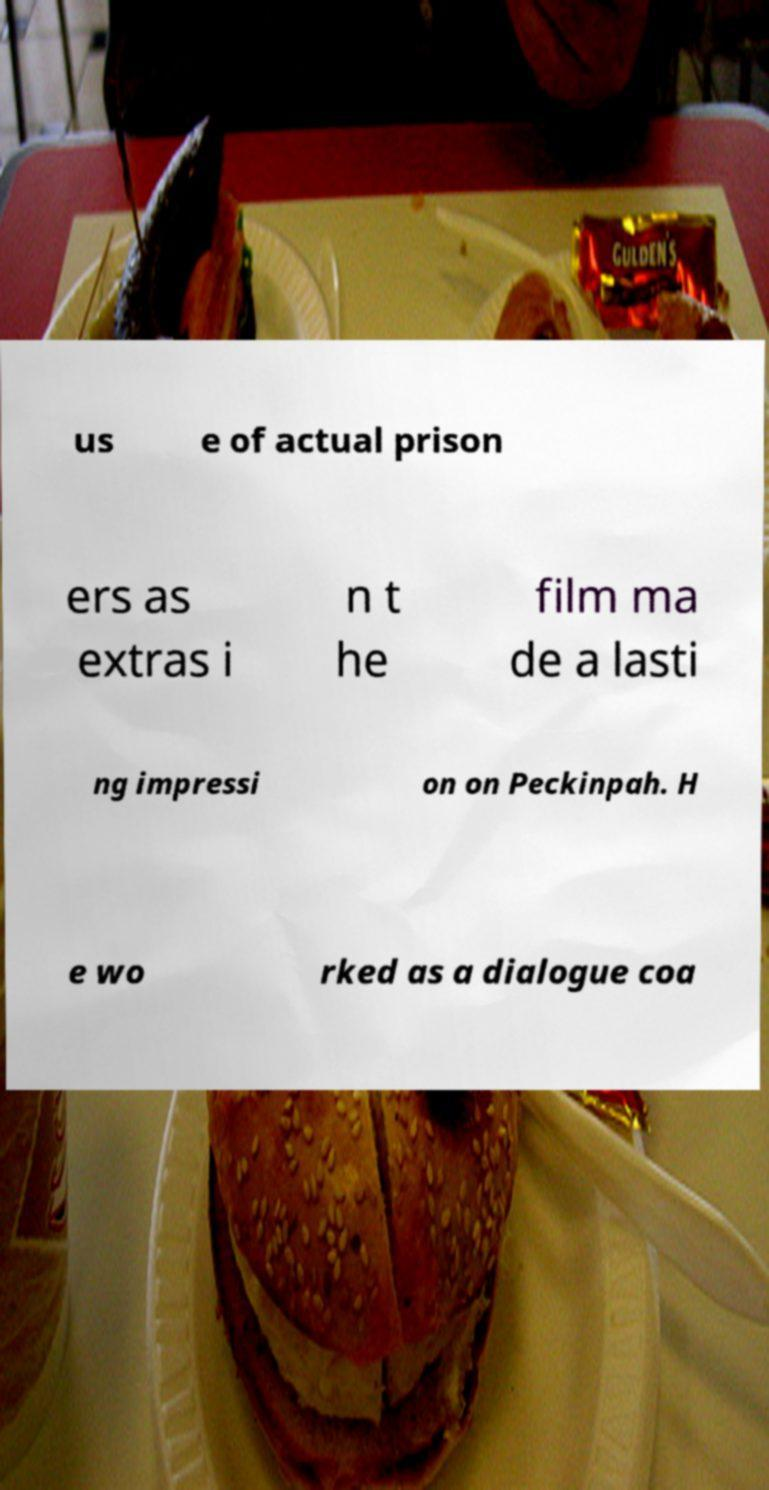I need the written content from this picture converted into text. Can you do that? us e of actual prison ers as extras i n t he film ma de a lasti ng impressi on on Peckinpah. H e wo rked as a dialogue coa 